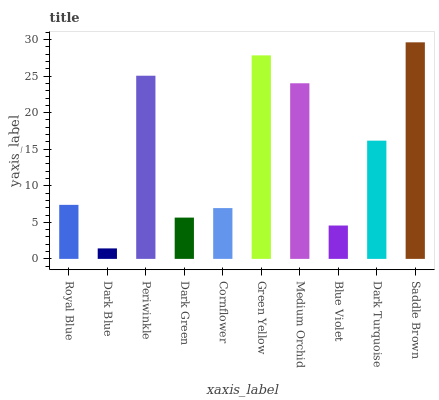Is Dark Blue the minimum?
Answer yes or no. Yes. Is Saddle Brown the maximum?
Answer yes or no. Yes. Is Periwinkle the minimum?
Answer yes or no. No. Is Periwinkle the maximum?
Answer yes or no. No. Is Periwinkle greater than Dark Blue?
Answer yes or no. Yes. Is Dark Blue less than Periwinkle?
Answer yes or no. Yes. Is Dark Blue greater than Periwinkle?
Answer yes or no. No. Is Periwinkle less than Dark Blue?
Answer yes or no. No. Is Dark Turquoise the high median?
Answer yes or no. Yes. Is Royal Blue the low median?
Answer yes or no. Yes. Is Cornflower the high median?
Answer yes or no. No. Is Blue Violet the low median?
Answer yes or no. No. 